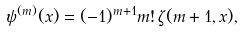<formula> <loc_0><loc_0><loc_500><loc_500>\psi ^ { ( m ) } ( x ) = ( - 1 ) ^ { m + 1 } m ! \, \zeta ( m + 1 , x ) ,</formula> 